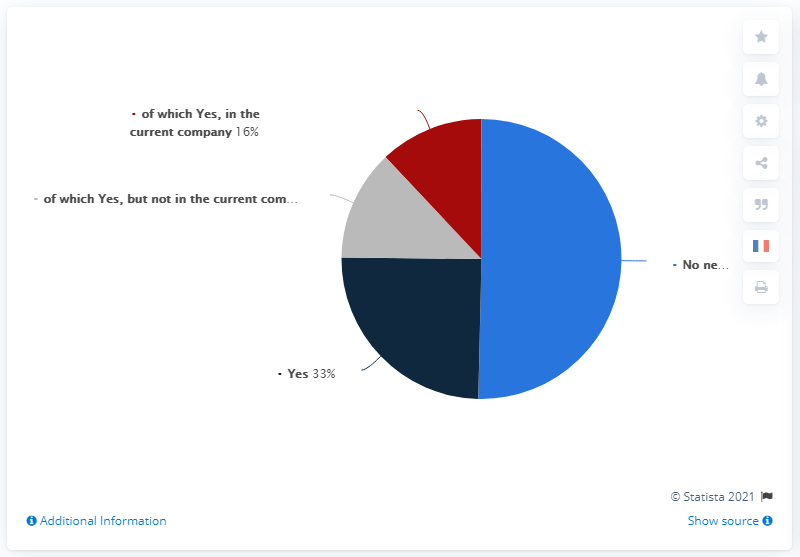Identify some key points in this picture. The color of the pie segment that represents a positive response is dark blue. The sum total of "Yes" and "Yes" in the current company is 49. 